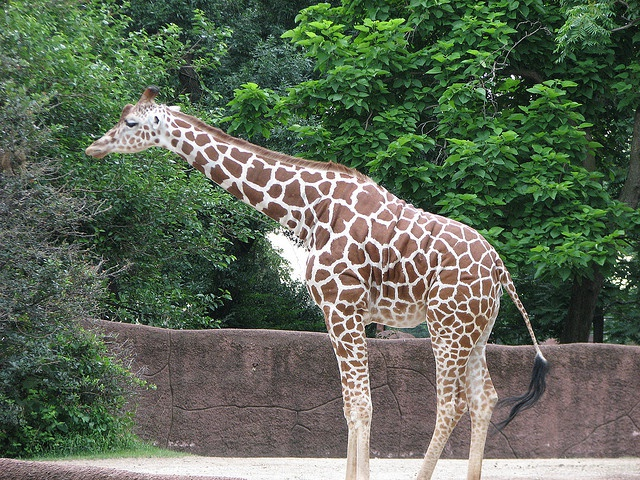Describe the objects in this image and their specific colors. I can see a giraffe in darkgreen, lightgray, gray, and darkgray tones in this image. 